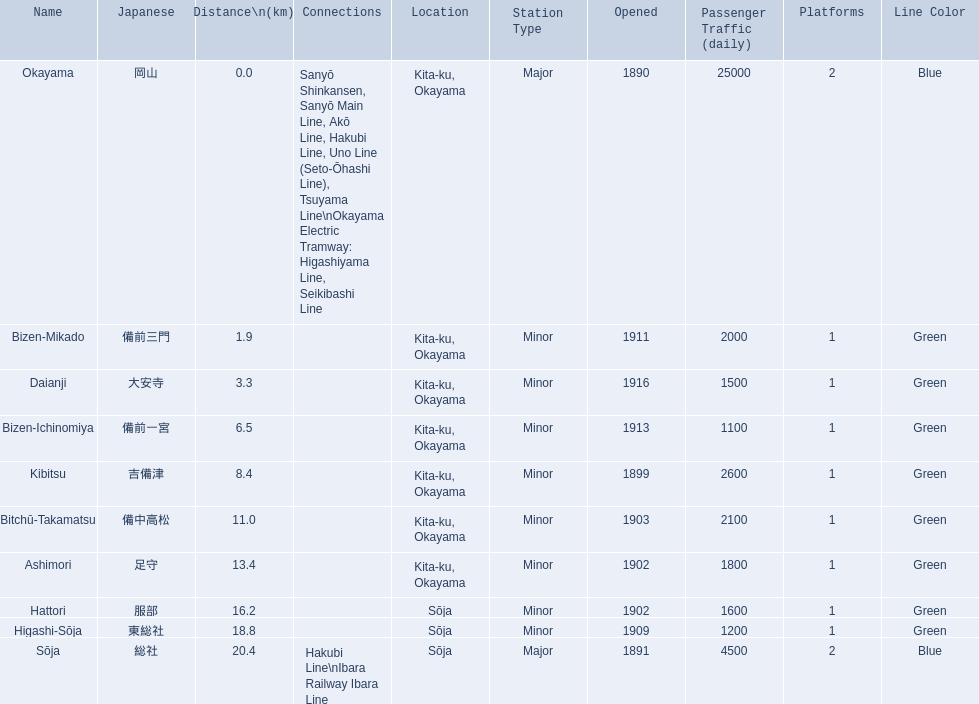What are the members of the kibi line? Okayama, Bizen-Mikado, Daianji, Bizen-Ichinomiya, Kibitsu, Bitchū-Takamatsu, Ashimori, Hattori, Higashi-Sōja, Sōja. Write the full table. {'header': ['Name', 'Japanese', 'Distance\\n(km)', 'Connections', 'Location', 'Station Type', 'Opened', 'Passenger Traffic (daily)', 'Platforms', 'Line Color'], 'rows': [['Okayama', '岡山', '0.0', 'Sanyō Shinkansen, Sanyō Main Line, Akō Line, Hakubi Line, Uno Line (Seto-Ōhashi Line), Tsuyama Line\\nOkayama Electric Tramway: Higashiyama Line, Seikibashi Line', 'Kita-ku, Okayama', 'Major', '1890', '25000', '2', 'Blue'], ['Bizen-Mikado', '備前三門', '1.9', '', 'Kita-ku, Okayama', 'Minor', '1911', '2000', '1', 'Green'], ['Daianji', '大安寺', '3.3', '', 'Kita-ku, Okayama', 'Minor', '1916', '1500', '1', 'Green'], ['Bizen-Ichinomiya', '備前一宮', '6.5', '', 'Kita-ku, Okayama', 'Minor', '1913', '1100', '1', 'Green'], ['Kibitsu', '吉備津', '8.4', '', 'Kita-ku, Okayama', 'Minor', '1899', '2600', '1', 'Green'], ['Bitchū-Takamatsu', '備中高松', '11.0', '', 'Kita-ku, Okayama', 'Minor', '1903', '2100', '1', 'Green'], ['Ashimori', '足守', '13.4', '', 'Kita-ku, Okayama', 'Minor', '1902', '1800', '1', 'Green'], ['Hattori', '服部', '16.2', '', 'Sōja', 'Minor', '1902', '1600', '1', 'Green'], ['Higashi-Sōja', '東総社', '18.8', '', 'Sōja', 'Minor', '1909', '1200', '1', 'Green'], ['Sōja', '総社', '20.4', 'Hakubi Line\\nIbara Railway Ibara Line', 'Sōja', 'Major', '1891', '4500', '2', 'Blue']]} Which of them have a distance of more than 1 km? Bizen-Mikado, Daianji, Bizen-Ichinomiya, Kibitsu, Bitchū-Takamatsu, Ashimori, Hattori, Higashi-Sōja, Sōja. Which of them have a distance of less than 2 km? Okayama, Bizen-Mikado. Which has a distance between 1 km and 2 km? Bizen-Mikado. 